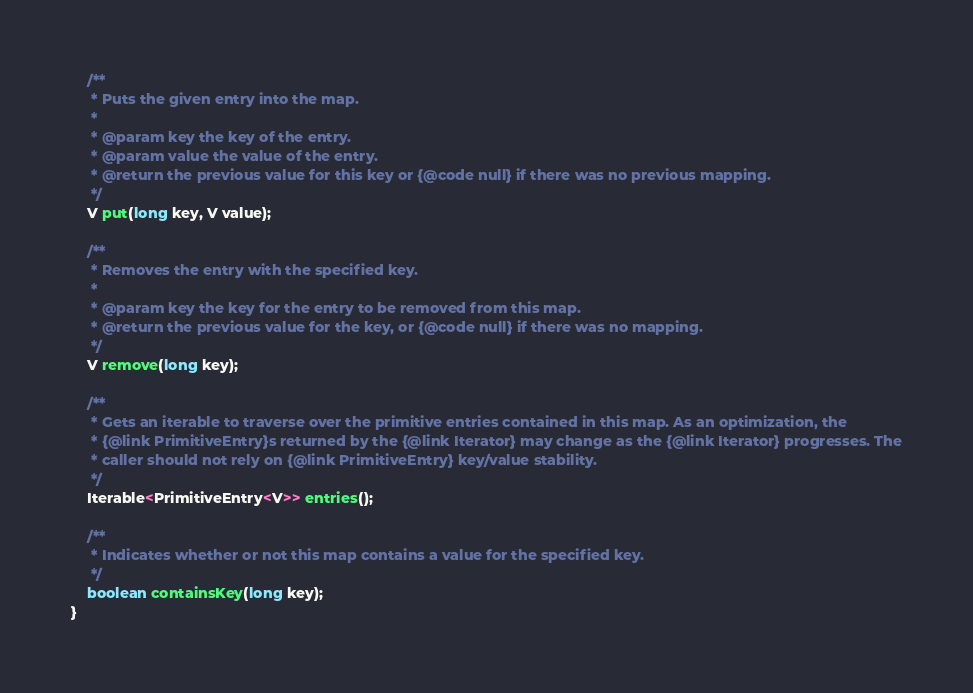Convert code to text. <code><loc_0><loc_0><loc_500><loc_500><_Java_>
	/**
	 * Puts the given entry into the map.
	 *
	 * @param key the key of the entry.
	 * @param value the value of the entry.
	 * @return the previous value for this key or {@code null} if there was no previous mapping.
	 */
	V put(long key, V value);

	/**
	 * Removes the entry with the specified key.
	 *
	 * @param key the key for the entry to be removed from this map.
	 * @return the previous value for the key, or {@code null} if there was no mapping.
	 */
	V remove(long key);

	/**
	 * Gets an iterable to traverse over the primitive entries contained in this map. As an optimization, the
	 * {@link PrimitiveEntry}s returned by the {@link Iterator} may change as the {@link Iterator} progresses. The
	 * caller should not rely on {@link PrimitiveEntry} key/value stability.
	 */
	Iterable<PrimitiveEntry<V>> entries();

	/**
	 * Indicates whether or not this map contains a value for the specified key.
	 */
	boolean containsKey(long key);
}
</code> 